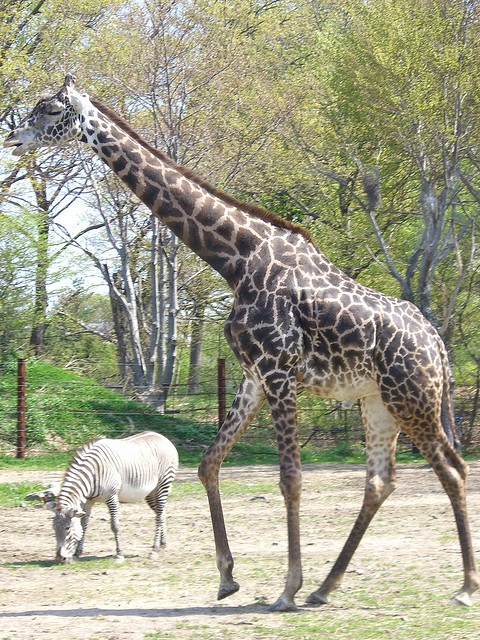Describe the objects in this image and their specific colors. I can see giraffe in olive, gray, darkgray, black, and white tones and zebra in olive, white, darkgray, gray, and lightgray tones in this image. 